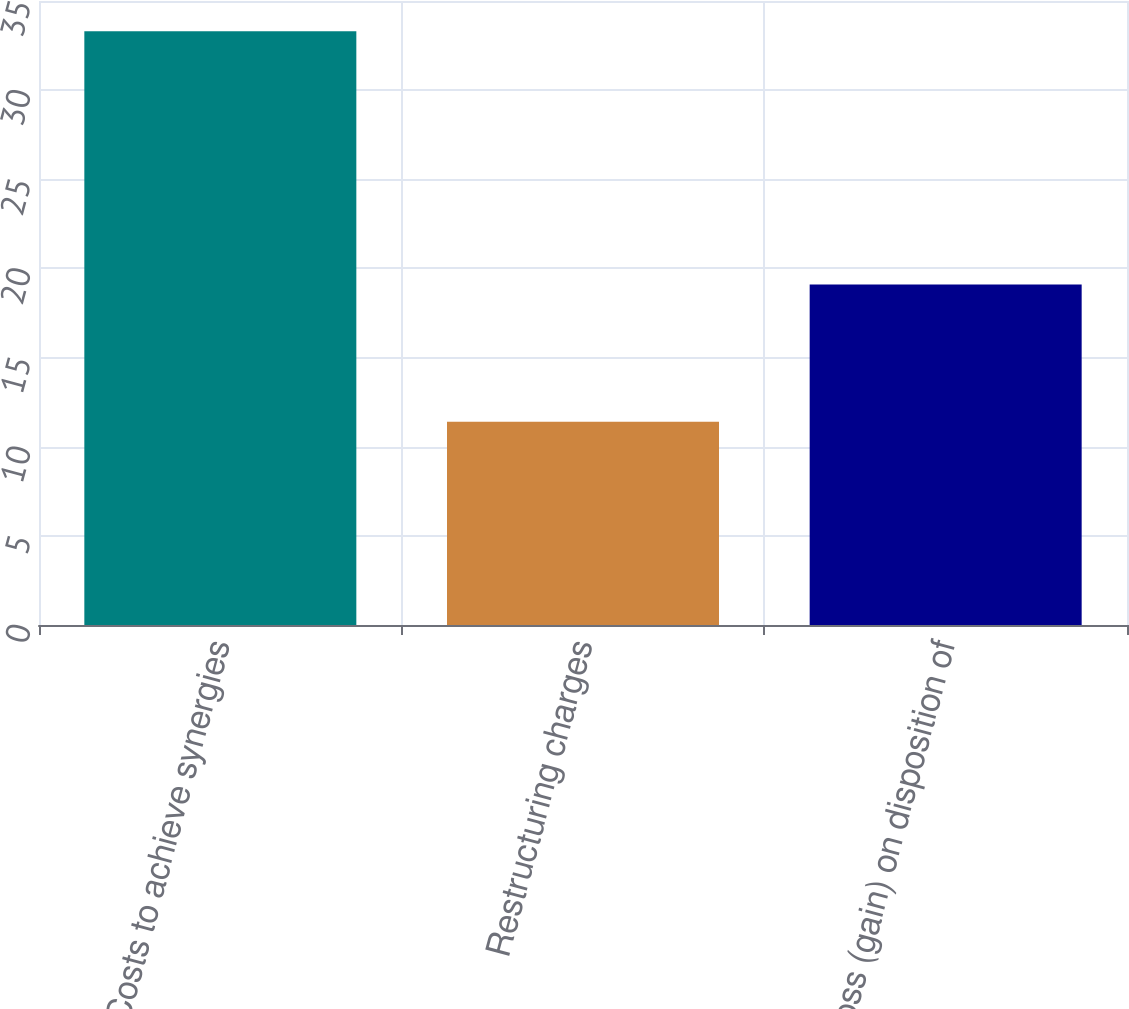<chart> <loc_0><loc_0><loc_500><loc_500><bar_chart><fcel>Costs to achieve synergies<fcel>Restructuring charges<fcel>Loss (gain) on disposition of<nl><fcel>33.3<fcel>11.4<fcel>19.1<nl></chart> 